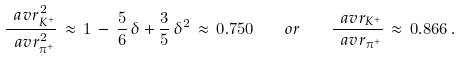<formula> <loc_0><loc_0><loc_500><loc_500>\frac { \ a v { r _ { K ^ { + } } ^ { 2 } } } { \ a v { r _ { \pi ^ { + } } ^ { 2 } } } \, \approx \, 1 \, - \, \frac { 5 } { 6 } \, \delta + \frac { 3 } { 5 } \, \delta ^ { 2 } \, \approx \, 0 . 7 5 0 \quad o r \quad \frac { \ a v { r _ { K ^ { + } } } } { \ a v { r _ { \pi ^ { + } } } } \, \approx \, 0 . 8 6 6 \, .</formula> 